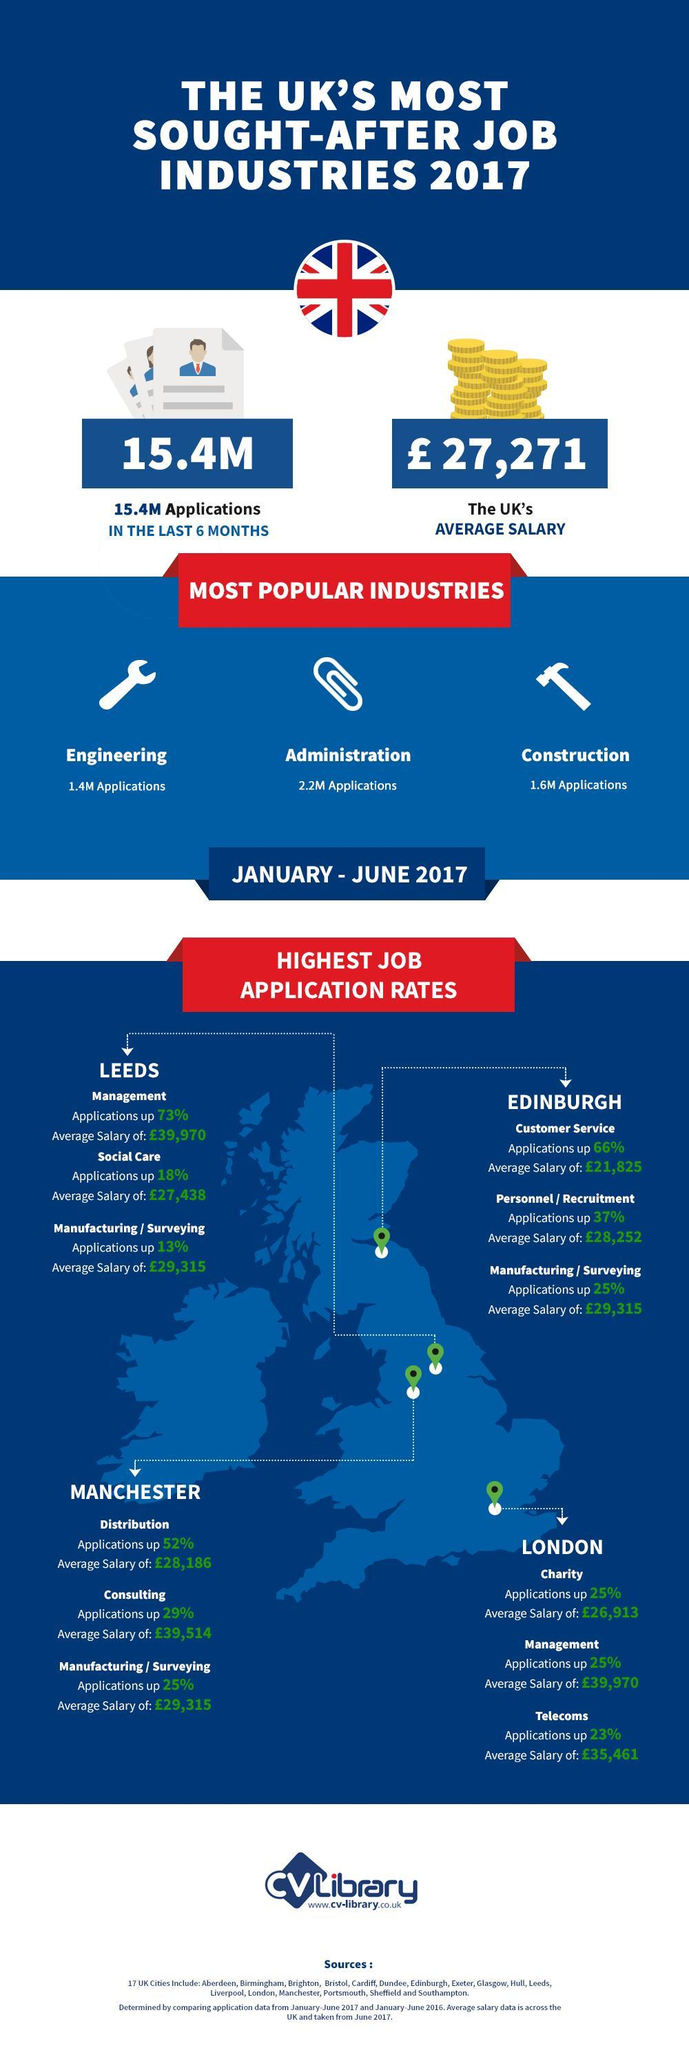Which industry in Manchester had highest increase in job application rate from January-June 2017?
Answer the question with a short phrase. Distribution What is the average salary of Telecom jobs in London from January-June 2017? £35,461 Which industry in Leeds had highest increase in job application rate from January-June 2017? Management What is the average salary of social care jobs in Leeds from January-June 2017? £27,432 What is the average salary of customer services jobs in Edinburgh from January-June 2017? £21,825 What is the UK's average salary in 2017? £ 27,271 Which industry in Manchester had least increase in job application rate from January-June 2017? Manufacturing / Surveying 